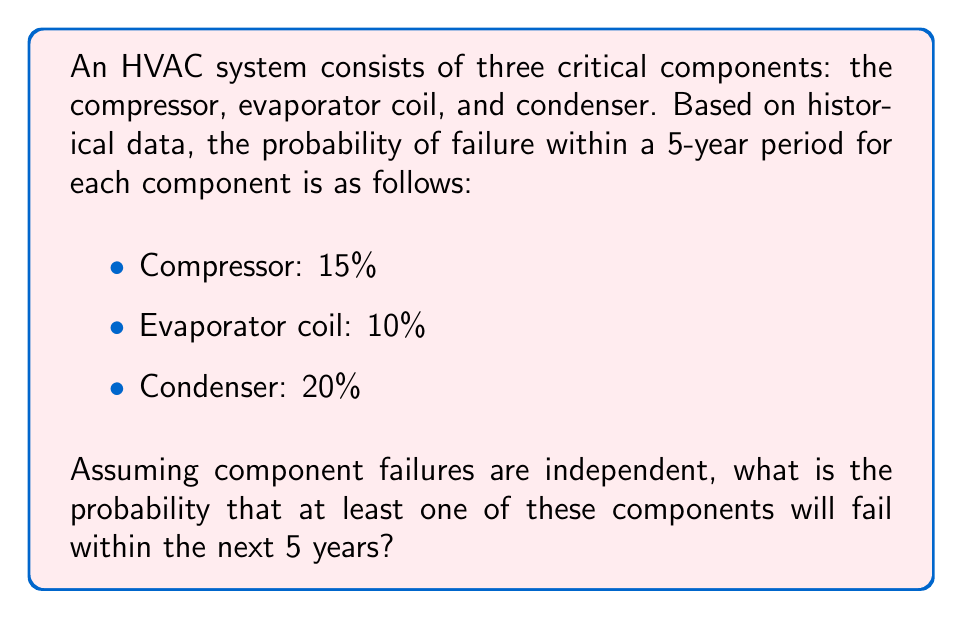Provide a solution to this math problem. To solve this problem, we'll use the complement rule of probability theory. Instead of calculating the probability of at least one component failing, we'll calculate the probability of no components failing and then subtract that from 1.

Step 1: Calculate the probability of each component not failing:
- Compressor: $1 - 0.15 = 0.85$
- Evaporator coil: $1 - 0.10 = 0.90$
- Condenser: $1 - 0.20 = 0.80$

Step 2: Calculate the probability of all components not failing (since failures are independent, we multiply these probabilities):

$$P(\text{no failures}) = 0.85 \times 0.90 \times 0.80 = 0.612$$

Step 3: Calculate the probability of at least one component failing using the complement rule:

$$P(\text{at least one failure}) = 1 - P(\text{no failures}) = 1 - 0.612 = 0.388$$

Step 4: Convert to a percentage:

$$0.388 \times 100\% = 38.8\%$$

Therefore, the probability that at least one of these components will fail within the next 5 years is 38.8%.
Answer: 38.8% 